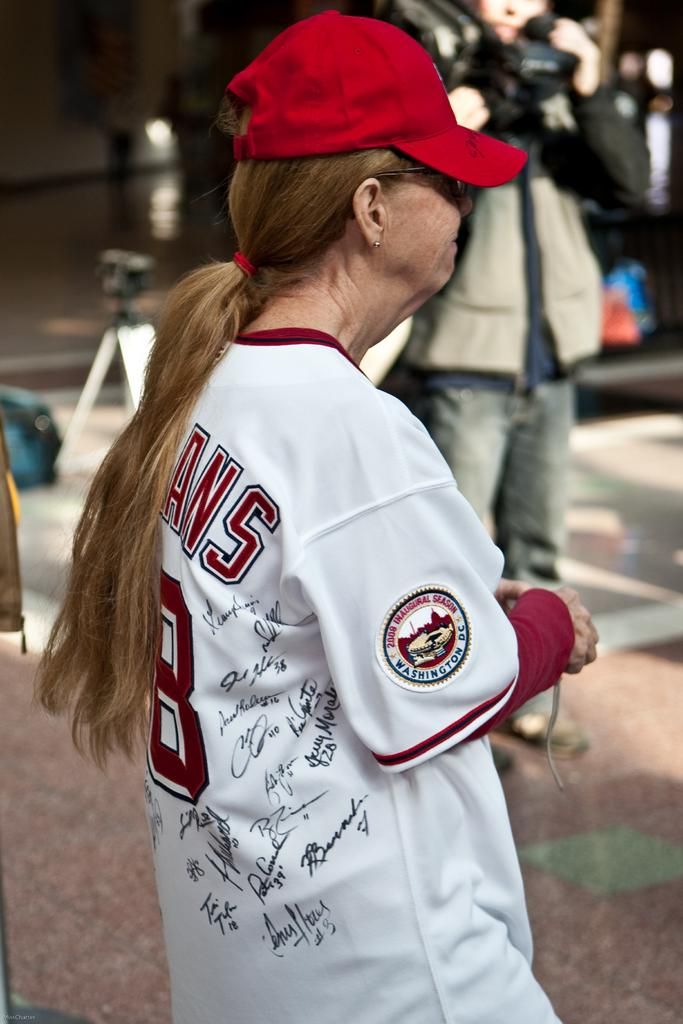<image>
Describe the image concisely. A lady wearing a signed baseball jersey for the Washington Indians. 